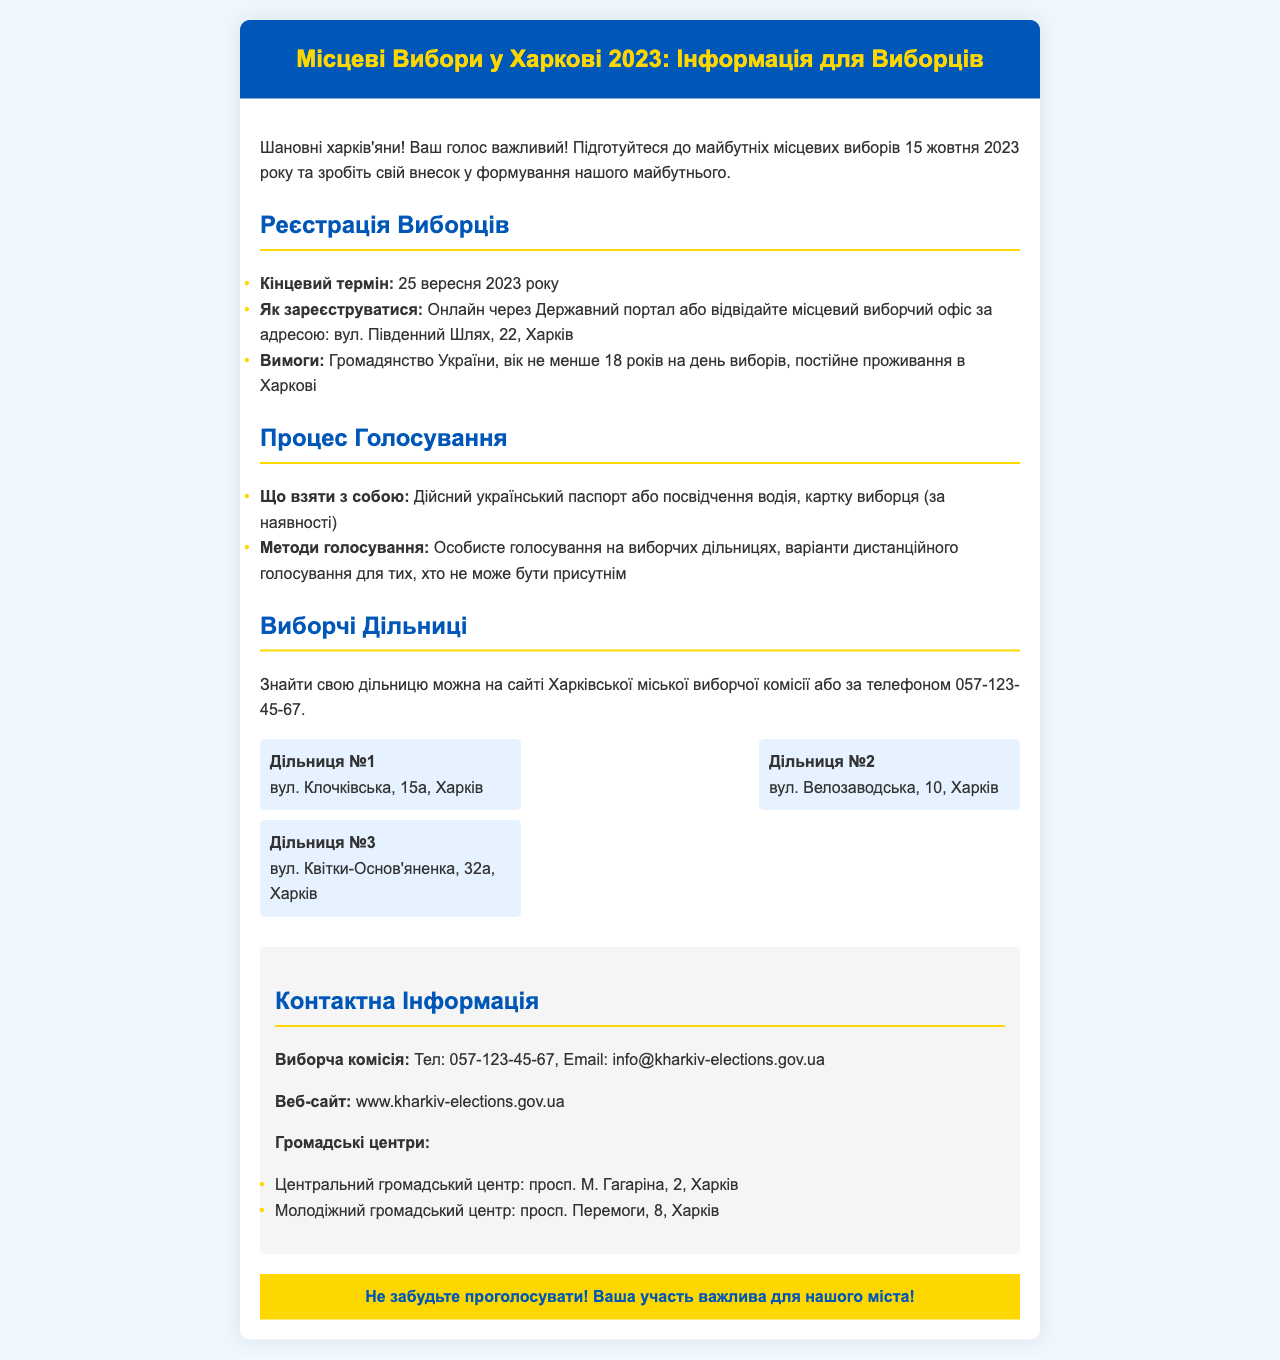What is the date of the local elections? The document states the local elections will be held on 15th October 2023.
Answer: 15 жовтня 2023 року What is the registration deadline for voters? The document mentions that the deadline for voter registration is 25th September 2023.
Answer: 25 вересня 2023 року Where is the local election office located? The document provides the address of the local election office as вул. Південний Шлях, 22, Харків.
Answer: вул. Південний Шлях, 22, Харків What do voters need to bring to the polling station? The document specifies that voters should bring a valid Ukrainian passport or driver's license and a voter card if available.
Answer: Дійсний український паспорт або посвідчення водія, картка виборця (за наявності) How many polling stations are mentioned in the document? The document lists three polling stations in total.
Answer: 3 What is the contact email for the election commission? The document provides the contact email for the election commission, which is info@kharkiv-elections.gov.ua.
Answer: info@kharkiv-elections.gov.ua What is the address of Polling Station No. 2? The document states that Polling Station No. 2 is located at вул. Велозаводська, 10, Харків.
Answer: вул. Велозаводська, 10, Харків What kind of voting methods are mentioned? The document mentions personal voting at polling stations and options for remote voting for those unable to attend.
Answer: Особисте голосування, дистанційне голосування What is the reminder emphasized at the bottom of the brochure? The document emphasizes that participation is important for the city and reminds voters not to forget to vote.
Answer: Не забудьте проголосувати! 